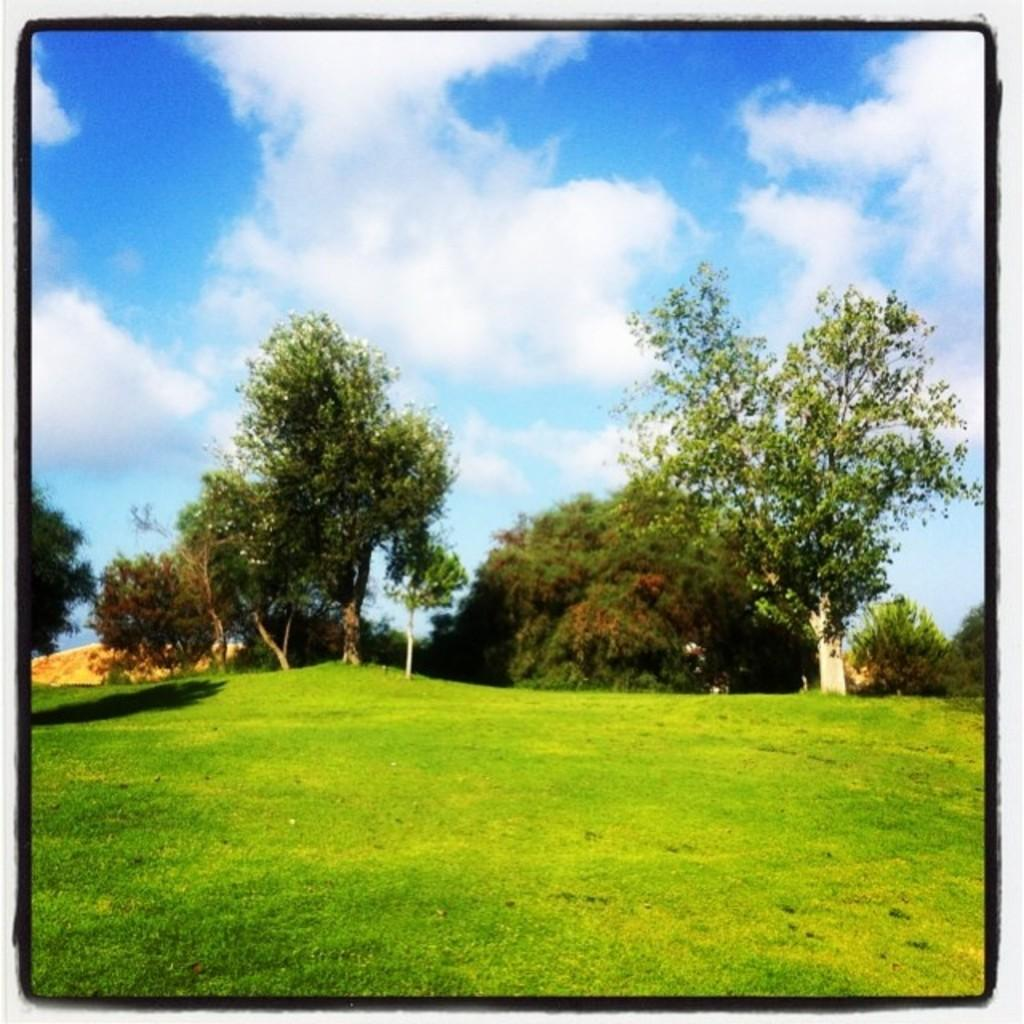What type of vegetation can be seen in the image? There are trees and grass in the image. What is visible in the background of the image? The sky is visible in the image. What can be observed in the sky? Clouds are present in the sky. How are the elements in the image framed? The image has borders. How does the mother in the image show respect to the trees? There is no mother present in the image, and therefore no such interaction can be observed. 